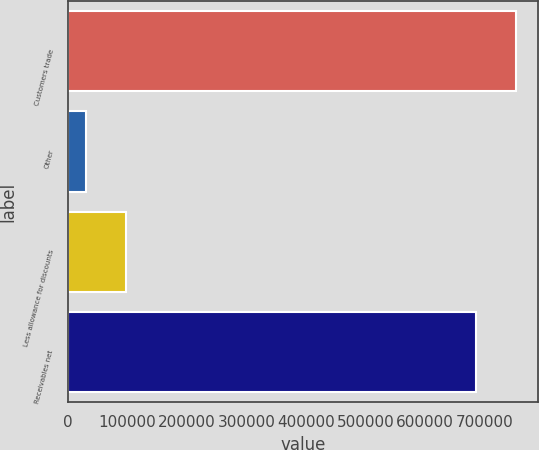<chart> <loc_0><loc_0><loc_500><loc_500><bar_chart><fcel>Customers trade<fcel>Other<fcel>Less allowance for discounts<fcel>Receivables net<nl><fcel>752720<fcel>31311<fcel>97865.5<fcel>686165<nl></chart> 